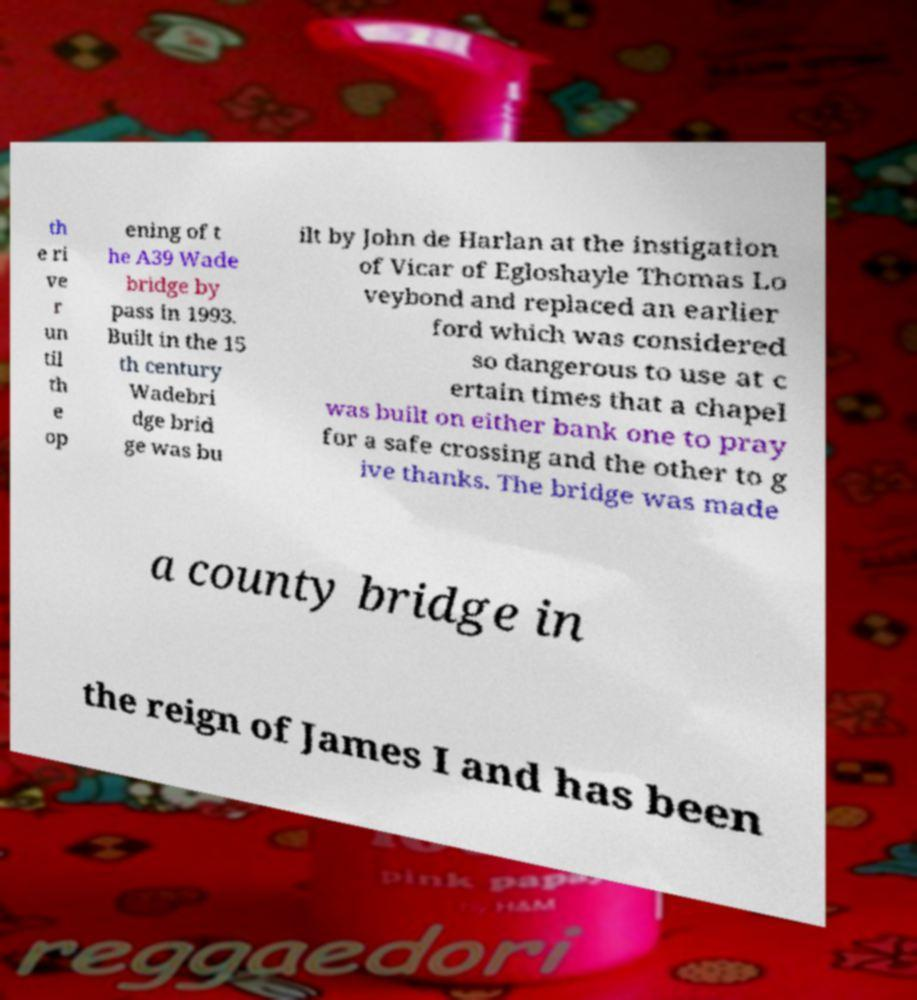Please identify and transcribe the text found in this image. th e ri ve r un til th e op ening of t he A39 Wade bridge by pass in 1993. Built in the 15 th century Wadebri dge brid ge was bu ilt by John de Harlan at the instigation of Vicar of Egloshayle Thomas Lo veybond and replaced an earlier ford which was considered so dangerous to use at c ertain times that a chapel was built on either bank one to pray for a safe crossing and the other to g ive thanks. The bridge was made a county bridge in the reign of James I and has been 